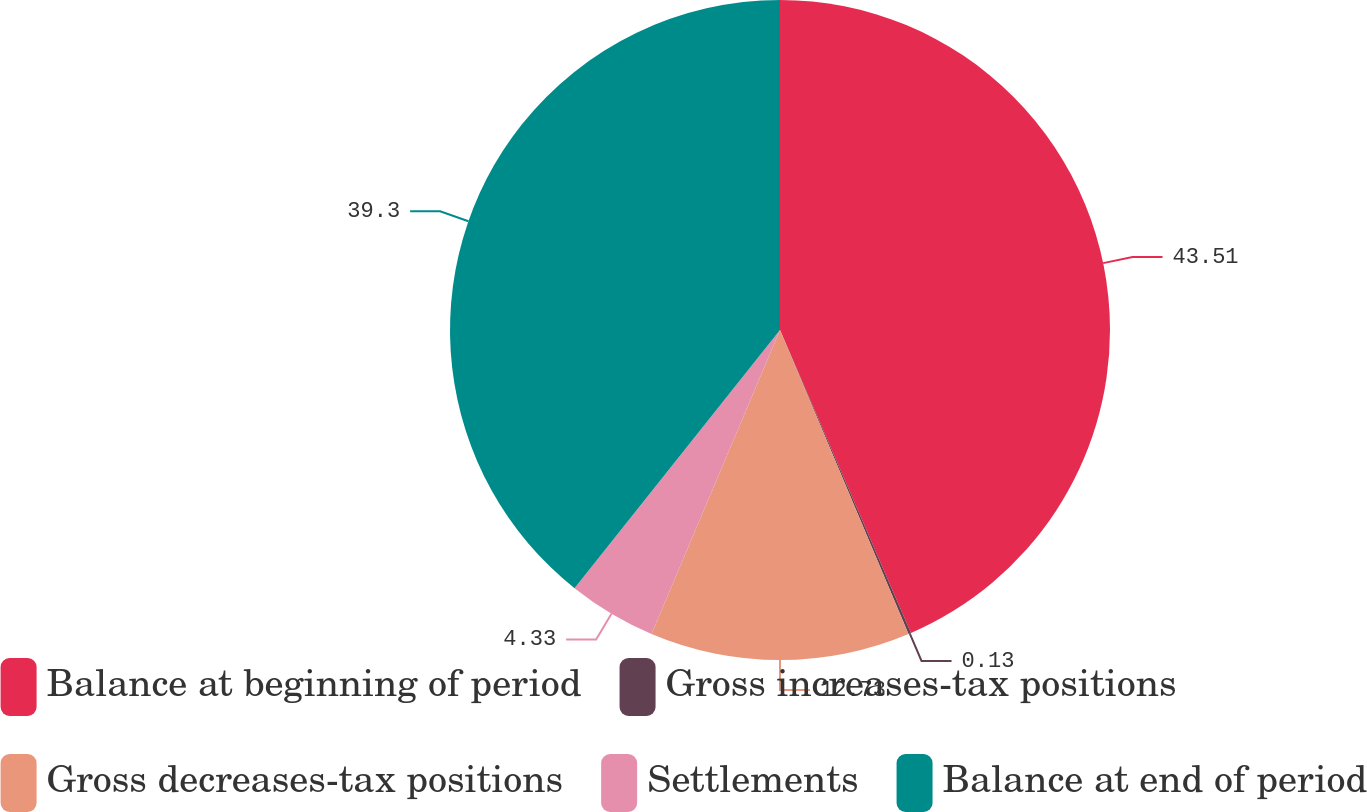<chart> <loc_0><loc_0><loc_500><loc_500><pie_chart><fcel>Balance at beginning of period<fcel>Gross increases-tax positions<fcel>Gross decreases-tax positions<fcel>Settlements<fcel>Balance at end of period<nl><fcel>43.5%<fcel>0.13%<fcel>12.73%<fcel>4.33%<fcel>39.3%<nl></chart> 